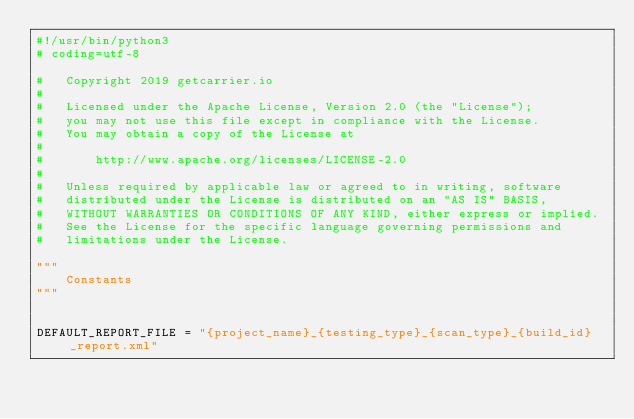<code> <loc_0><loc_0><loc_500><loc_500><_Python_>#!/usr/bin/python3
# coding=utf-8

#   Copyright 2019 getcarrier.io
#
#   Licensed under the Apache License, Version 2.0 (the "License");
#   you may not use this file except in compliance with the License.
#   You may obtain a copy of the License at
#
#       http://www.apache.org/licenses/LICENSE-2.0
#
#   Unless required by applicable law or agreed to in writing, software
#   distributed under the License is distributed on an "AS IS" BASIS,
#   WITHOUT WARRANTIES OR CONDITIONS OF ANY KIND, either express or implied.
#   See the License for the specific language governing permissions and
#   limitations under the License.

"""
    Constants
"""


DEFAULT_REPORT_FILE = "{project_name}_{testing_type}_{scan_type}_{build_id}_report.xml"
</code> 